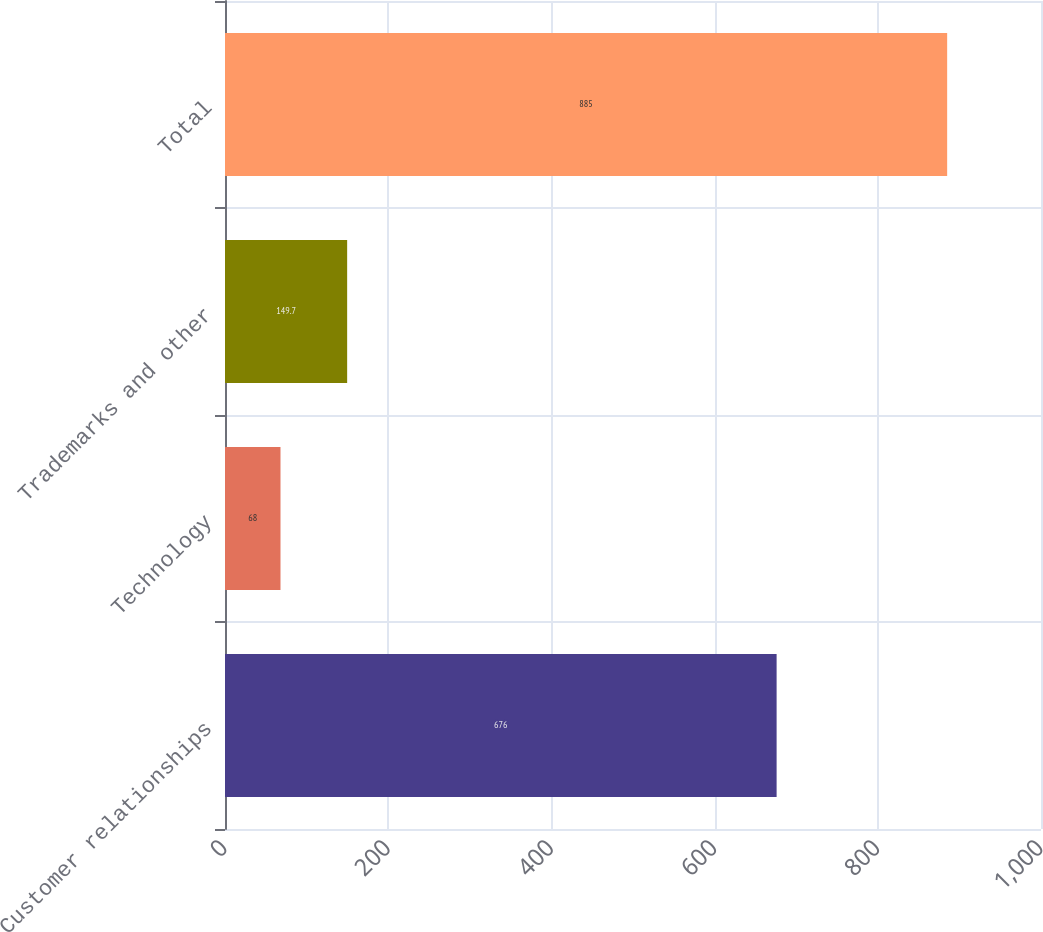Convert chart. <chart><loc_0><loc_0><loc_500><loc_500><bar_chart><fcel>Customer relationships<fcel>Technology<fcel>Trademarks and other<fcel>Total<nl><fcel>676<fcel>68<fcel>149.7<fcel>885<nl></chart> 